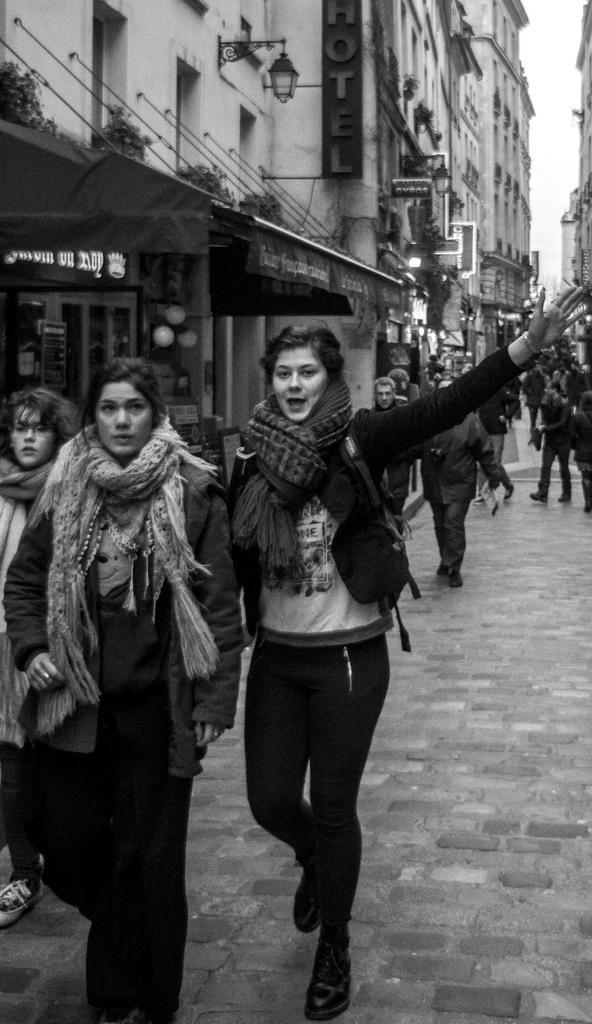How would you summarize this image in a sentence or two? This is a black and white pic. In this image we can see few persons are walking on the road. In the background we can see buildings, hoardings, poles, objects, name board the wall, tent and sky. 